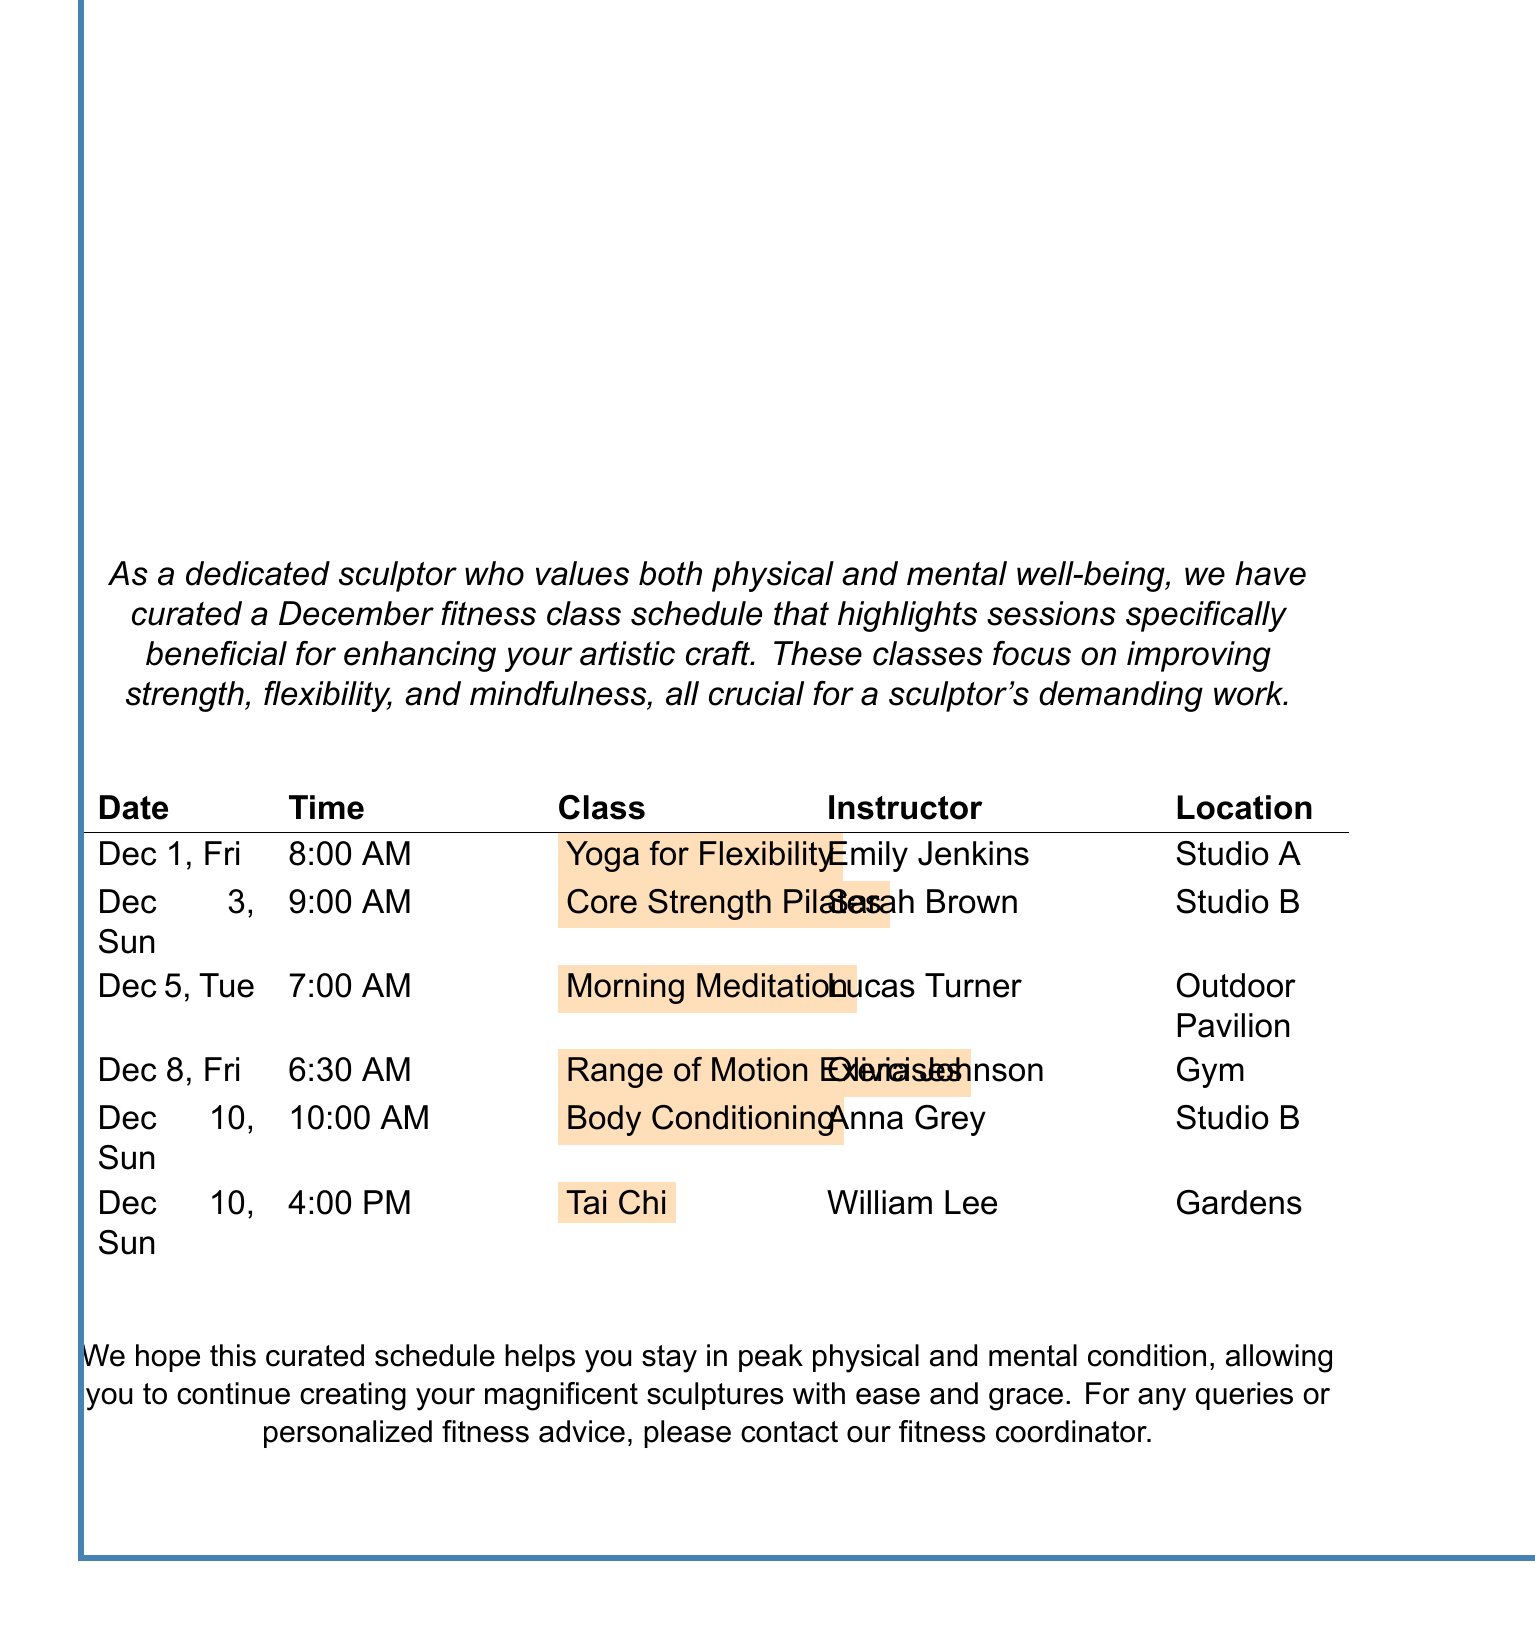What is the first class scheduled in December? The first class on the schedule is Yoga for Flexibility, which takes place on December 1.
Answer: Yoga for Flexibility Who is the instructor for the Core Strength Pilates class? The instructor for the Core Strength Pilates class, scheduled for December 3, is Sarah Brown.
Answer: Sarah Brown What time does the Morning Meditation class start? The Morning Meditation class is scheduled to start at 7:00 AM on December 5.
Answer: 7:00 AM What location is listed for the Tai Chi class? The Tai Chi class on December 10 is held in the Gardens.
Answer: Gardens How many recommended sessions for sculptors are there in total? There are six highlighted recommended sessions for sculptors in the class schedule.
Answer: Six 